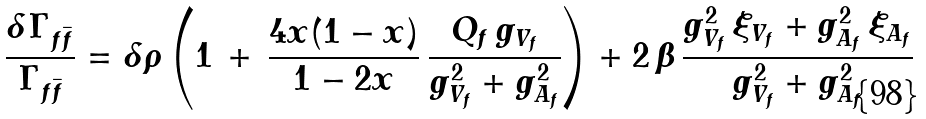<formula> <loc_0><loc_0><loc_500><loc_500>\frac { \delta \Gamma _ { f \bar { f } } } { \Gamma _ { f \bar { f } } } = \delta \rho \left ( 1 \, + \, \frac { 4 x ( 1 - x ) } { 1 - 2 x } \, \frac { Q _ { f } \, g _ { V _ { f } } } { g _ { V _ { f } } ^ { 2 } + g _ { A _ { f } } ^ { 2 } } \right ) + 2 \, \beta \, \frac { g _ { V _ { f } } ^ { 2 } \, \xi _ { V _ { f } } + g _ { A _ { f } } ^ { 2 } \, \xi _ { A _ { f } } } { g _ { V _ { f } } ^ { 2 } + g _ { A _ { f } } ^ { 2 } }</formula> 